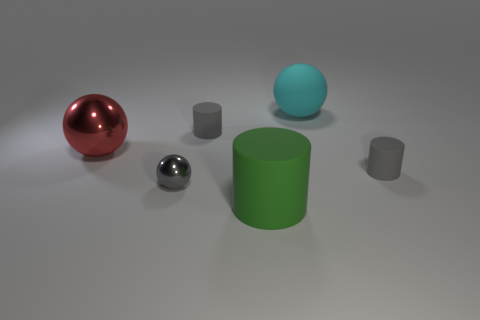Add 2 brown shiny objects. How many objects exist? 8 Subtract 0 red cylinders. How many objects are left? 6 Subtract all tiny gray balls. Subtract all big matte spheres. How many objects are left? 4 Add 4 cyan matte spheres. How many cyan matte spheres are left? 5 Add 2 gray balls. How many gray balls exist? 3 